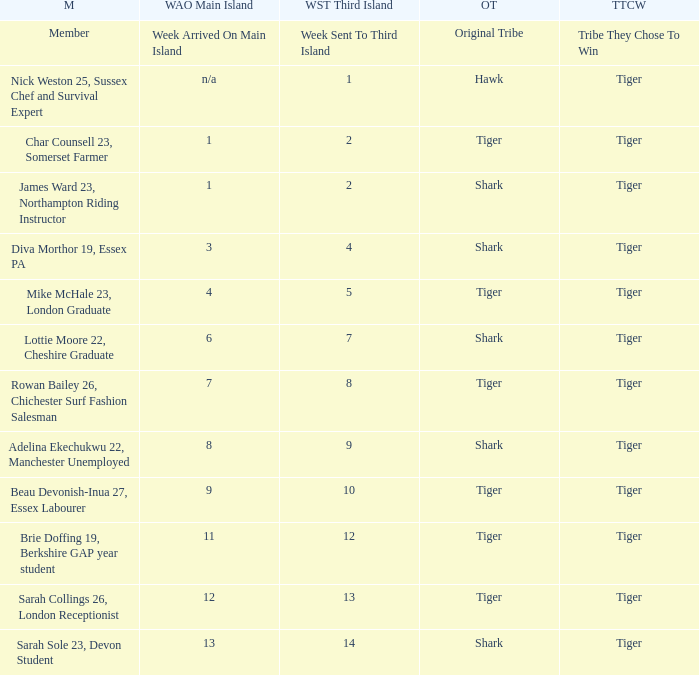How many members arrived on the main island in week 4? 1.0. 